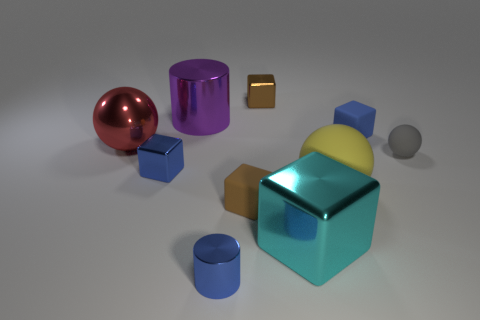What material is the blue cylinder?
Your response must be concise. Metal. There is a blue object behind the blue cube to the left of the cylinder in front of the big cylinder; what is its shape?
Your answer should be very brief. Cube. How many other objects are the same material as the gray sphere?
Provide a succinct answer. 3. Do the small blue thing that is to the right of the brown metal thing and the brown thing behind the tiny gray ball have the same material?
Keep it short and to the point. No. How many objects are behind the small gray ball and on the right side of the yellow rubber thing?
Provide a succinct answer. 1. Are there any big yellow rubber things of the same shape as the large red thing?
Make the answer very short. Yes. The yellow object that is the same size as the purple cylinder is what shape?
Keep it short and to the point. Sphere. Is the number of purple metallic cylinders that are to the right of the large cyan metal object the same as the number of tiny cylinders that are behind the big rubber sphere?
Ensure brevity in your answer.  Yes. What is the size of the blue cube that is to the left of the small block to the right of the big yellow sphere?
Ensure brevity in your answer.  Small. Are there any yellow rubber spheres of the same size as the purple cylinder?
Your response must be concise. Yes. 